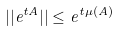Convert formula to latex. <formula><loc_0><loc_0><loc_500><loc_500>| | e ^ { t A } | | \leq e ^ { t \mu ( A ) }</formula> 